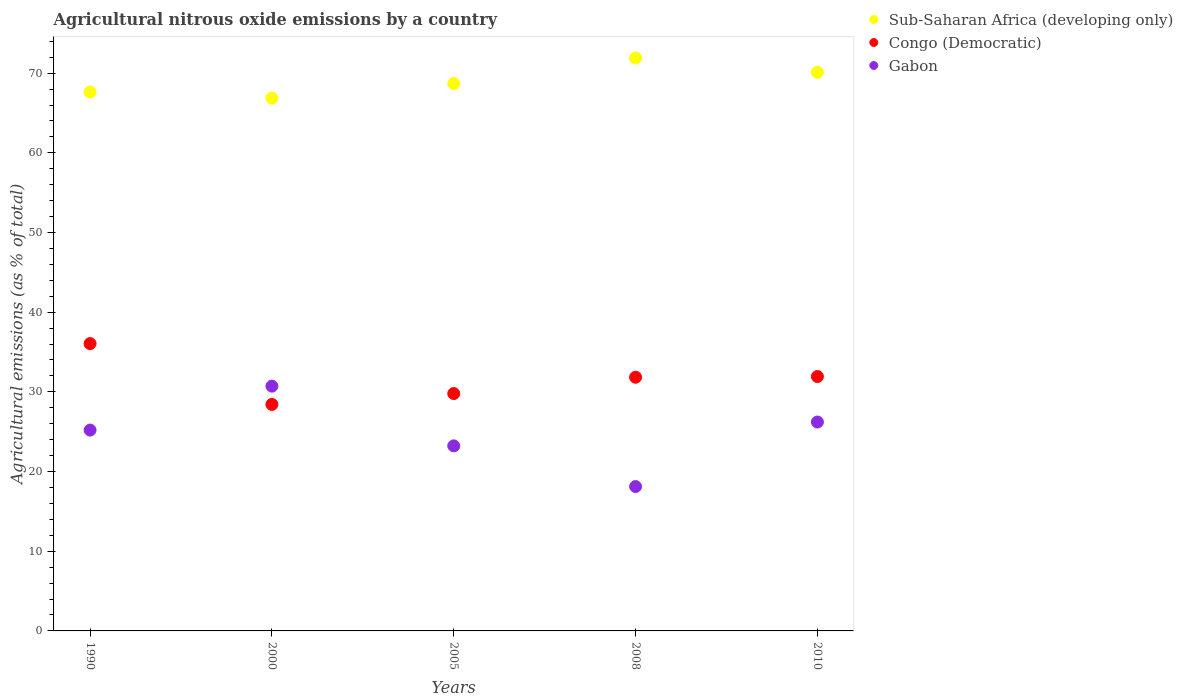How many different coloured dotlines are there?
Offer a very short reply. 3. Is the number of dotlines equal to the number of legend labels?
Provide a short and direct response. Yes. What is the amount of agricultural nitrous oxide emitted in Congo (Democratic) in 1990?
Ensure brevity in your answer.  36.06. Across all years, what is the maximum amount of agricultural nitrous oxide emitted in Gabon?
Offer a very short reply. 30.72. Across all years, what is the minimum amount of agricultural nitrous oxide emitted in Congo (Democratic)?
Offer a very short reply. 28.43. In which year was the amount of agricultural nitrous oxide emitted in Sub-Saharan Africa (developing only) maximum?
Your answer should be compact. 2008. In which year was the amount of agricultural nitrous oxide emitted in Congo (Democratic) minimum?
Give a very brief answer. 2000. What is the total amount of agricultural nitrous oxide emitted in Congo (Democratic) in the graph?
Your response must be concise. 158.03. What is the difference between the amount of agricultural nitrous oxide emitted in Gabon in 2000 and that in 2010?
Provide a succinct answer. 4.5. What is the difference between the amount of agricultural nitrous oxide emitted in Sub-Saharan Africa (developing only) in 2005 and the amount of agricultural nitrous oxide emitted in Gabon in 1990?
Provide a succinct answer. 43.49. What is the average amount of agricultural nitrous oxide emitted in Congo (Democratic) per year?
Keep it short and to the point. 31.61. In the year 2000, what is the difference between the amount of agricultural nitrous oxide emitted in Sub-Saharan Africa (developing only) and amount of agricultural nitrous oxide emitted in Gabon?
Your answer should be very brief. 36.14. What is the ratio of the amount of agricultural nitrous oxide emitted in Sub-Saharan Africa (developing only) in 2000 to that in 2005?
Your answer should be compact. 0.97. Is the amount of agricultural nitrous oxide emitted in Congo (Democratic) in 1990 less than that in 2010?
Your answer should be very brief. No. Is the difference between the amount of agricultural nitrous oxide emitted in Sub-Saharan Africa (developing only) in 2005 and 2008 greater than the difference between the amount of agricultural nitrous oxide emitted in Gabon in 2005 and 2008?
Your response must be concise. No. What is the difference between the highest and the second highest amount of agricultural nitrous oxide emitted in Congo (Democratic)?
Offer a very short reply. 4.13. What is the difference between the highest and the lowest amount of agricultural nitrous oxide emitted in Congo (Democratic)?
Offer a terse response. 7.63. In how many years, is the amount of agricultural nitrous oxide emitted in Gabon greater than the average amount of agricultural nitrous oxide emitted in Gabon taken over all years?
Ensure brevity in your answer.  3. Is the sum of the amount of agricultural nitrous oxide emitted in Congo (Democratic) in 1990 and 2010 greater than the maximum amount of agricultural nitrous oxide emitted in Sub-Saharan Africa (developing only) across all years?
Ensure brevity in your answer.  No. How many dotlines are there?
Offer a very short reply. 3. How many years are there in the graph?
Offer a very short reply. 5. Does the graph contain grids?
Offer a terse response. No. Where does the legend appear in the graph?
Your answer should be compact. Top right. How many legend labels are there?
Your answer should be very brief. 3. What is the title of the graph?
Your answer should be compact. Agricultural nitrous oxide emissions by a country. Does "Macao" appear as one of the legend labels in the graph?
Give a very brief answer. No. What is the label or title of the X-axis?
Keep it short and to the point. Years. What is the label or title of the Y-axis?
Your answer should be compact. Agricultural emissions (as % of total). What is the Agricultural emissions (as % of total) of Sub-Saharan Africa (developing only) in 1990?
Keep it short and to the point. 67.62. What is the Agricultural emissions (as % of total) in Congo (Democratic) in 1990?
Make the answer very short. 36.06. What is the Agricultural emissions (as % of total) of Gabon in 1990?
Provide a succinct answer. 25.2. What is the Agricultural emissions (as % of total) of Sub-Saharan Africa (developing only) in 2000?
Your answer should be compact. 66.86. What is the Agricultural emissions (as % of total) of Congo (Democratic) in 2000?
Provide a succinct answer. 28.43. What is the Agricultural emissions (as % of total) of Gabon in 2000?
Give a very brief answer. 30.72. What is the Agricultural emissions (as % of total) in Sub-Saharan Africa (developing only) in 2005?
Your response must be concise. 68.7. What is the Agricultural emissions (as % of total) of Congo (Democratic) in 2005?
Your answer should be very brief. 29.79. What is the Agricultural emissions (as % of total) in Gabon in 2005?
Make the answer very short. 23.22. What is the Agricultural emissions (as % of total) in Sub-Saharan Africa (developing only) in 2008?
Your answer should be very brief. 71.9. What is the Agricultural emissions (as % of total) in Congo (Democratic) in 2008?
Make the answer very short. 31.84. What is the Agricultural emissions (as % of total) of Gabon in 2008?
Your response must be concise. 18.12. What is the Agricultural emissions (as % of total) of Sub-Saharan Africa (developing only) in 2010?
Your response must be concise. 70.1. What is the Agricultural emissions (as % of total) in Congo (Democratic) in 2010?
Ensure brevity in your answer.  31.92. What is the Agricultural emissions (as % of total) in Gabon in 2010?
Keep it short and to the point. 26.21. Across all years, what is the maximum Agricultural emissions (as % of total) in Sub-Saharan Africa (developing only)?
Offer a very short reply. 71.9. Across all years, what is the maximum Agricultural emissions (as % of total) in Congo (Democratic)?
Give a very brief answer. 36.06. Across all years, what is the maximum Agricultural emissions (as % of total) of Gabon?
Provide a succinct answer. 30.72. Across all years, what is the minimum Agricultural emissions (as % of total) of Sub-Saharan Africa (developing only)?
Give a very brief answer. 66.86. Across all years, what is the minimum Agricultural emissions (as % of total) in Congo (Democratic)?
Your answer should be compact. 28.43. Across all years, what is the minimum Agricultural emissions (as % of total) in Gabon?
Provide a succinct answer. 18.12. What is the total Agricultural emissions (as % of total) of Sub-Saharan Africa (developing only) in the graph?
Make the answer very short. 345.18. What is the total Agricultural emissions (as % of total) in Congo (Democratic) in the graph?
Your answer should be compact. 158.03. What is the total Agricultural emissions (as % of total) in Gabon in the graph?
Your response must be concise. 123.48. What is the difference between the Agricultural emissions (as % of total) of Sub-Saharan Africa (developing only) in 1990 and that in 2000?
Give a very brief answer. 0.76. What is the difference between the Agricultural emissions (as % of total) of Congo (Democratic) in 1990 and that in 2000?
Offer a terse response. 7.63. What is the difference between the Agricultural emissions (as % of total) of Gabon in 1990 and that in 2000?
Make the answer very short. -5.51. What is the difference between the Agricultural emissions (as % of total) in Sub-Saharan Africa (developing only) in 1990 and that in 2005?
Make the answer very short. -1.08. What is the difference between the Agricultural emissions (as % of total) of Congo (Democratic) in 1990 and that in 2005?
Ensure brevity in your answer.  6.27. What is the difference between the Agricultural emissions (as % of total) of Gabon in 1990 and that in 2005?
Make the answer very short. 1.98. What is the difference between the Agricultural emissions (as % of total) in Sub-Saharan Africa (developing only) in 1990 and that in 2008?
Provide a succinct answer. -4.28. What is the difference between the Agricultural emissions (as % of total) of Congo (Democratic) in 1990 and that in 2008?
Provide a short and direct response. 4.22. What is the difference between the Agricultural emissions (as % of total) in Gabon in 1990 and that in 2008?
Ensure brevity in your answer.  7.09. What is the difference between the Agricultural emissions (as % of total) in Sub-Saharan Africa (developing only) in 1990 and that in 2010?
Your answer should be compact. -2.48. What is the difference between the Agricultural emissions (as % of total) of Congo (Democratic) in 1990 and that in 2010?
Your response must be concise. 4.13. What is the difference between the Agricultural emissions (as % of total) in Gabon in 1990 and that in 2010?
Offer a very short reply. -1.01. What is the difference between the Agricultural emissions (as % of total) of Sub-Saharan Africa (developing only) in 2000 and that in 2005?
Your answer should be compact. -1.84. What is the difference between the Agricultural emissions (as % of total) in Congo (Democratic) in 2000 and that in 2005?
Give a very brief answer. -1.36. What is the difference between the Agricultural emissions (as % of total) of Gabon in 2000 and that in 2005?
Keep it short and to the point. 7.49. What is the difference between the Agricultural emissions (as % of total) of Sub-Saharan Africa (developing only) in 2000 and that in 2008?
Your response must be concise. -5.04. What is the difference between the Agricultural emissions (as % of total) of Congo (Democratic) in 2000 and that in 2008?
Your answer should be very brief. -3.41. What is the difference between the Agricultural emissions (as % of total) in Gabon in 2000 and that in 2008?
Ensure brevity in your answer.  12.6. What is the difference between the Agricultural emissions (as % of total) in Sub-Saharan Africa (developing only) in 2000 and that in 2010?
Provide a short and direct response. -3.24. What is the difference between the Agricultural emissions (as % of total) of Congo (Democratic) in 2000 and that in 2010?
Make the answer very short. -3.5. What is the difference between the Agricultural emissions (as % of total) of Gabon in 2000 and that in 2010?
Your answer should be compact. 4.5. What is the difference between the Agricultural emissions (as % of total) in Sub-Saharan Africa (developing only) in 2005 and that in 2008?
Offer a very short reply. -3.2. What is the difference between the Agricultural emissions (as % of total) of Congo (Democratic) in 2005 and that in 2008?
Make the answer very short. -2.05. What is the difference between the Agricultural emissions (as % of total) of Gabon in 2005 and that in 2008?
Your answer should be compact. 5.11. What is the difference between the Agricultural emissions (as % of total) of Sub-Saharan Africa (developing only) in 2005 and that in 2010?
Provide a succinct answer. -1.41. What is the difference between the Agricultural emissions (as % of total) of Congo (Democratic) in 2005 and that in 2010?
Give a very brief answer. -2.13. What is the difference between the Agricultural emissions (as % of total) of Gabon in 2005 and that in 2010?
Ensure brevity in your answer.  -2.99. What is the difference between the Agricultural emissions (as % of total) in Sub-Saharan Africa (developing only) in 2008 and that in 2010?
Make the answer very short. 1.79. What is the difference between the Agricultural emissions (as % of total) in Congo (Democratic) in 2008 and that in 2010?
Your answer should be very brief. -0.09. What is the difference between the Agricultural emissions (as % of total) in Gabon in 2008 and that in 2010?
Offer a terse response. -8.1. What is the difference between the Agricultural emissions (as % of total) of Sub-Saharan Africa (developing only) in 1990 and the Agricultural emissions (as % of total) of Congo (Democratic) in 2000?
Make the answer very short. 39.19. What is the difference between the Agricultural emissions (as % of total) in Sub-Saharan Africa (developing only) in 1990 and the Agricultural emissions (as % of total) in Gabon in 2000?
Give a very brief answer. 36.9. What is the difference between the Agricultural emissions (as % of total) of Congo (Democratic) in 1990 and the Agricultural emissions (as % of total) of Gabon in 2000?
Your response must be concise. 5.34. What is the difference between the Agricultural emissions (as % of total) in Sub-Saharan Africa (developing only) in 1990 and the Agricultural emissions (as % of total) in Congo (Democratic) in 2005?
Your answer should be very brief. 37.83. What is the difference between the Agricultural emissions (as % of total) in Sub-Saharan Africa (developing only) in 1990 and the Agricultural emissions (as % of total) in Gabon in 2005?
Provide a succinct answer. 44.4. What is the difference between the Agricultural emissions (as % of total) in Congo (Democratic) in 1990 and the Agricultural emissions (as % of total) in Gabon in 2005?
Make the answer very short. 12.83. What is the difference between the Agricultural emissions (as % of total) in Sub-Saharan Africa (developing only) in 1990 and the Agricultural emissions (as % of total) in Congo (Democratic) in 2008?
Ensure brevity in your answer.  35.78. What is the difference between the Agricultural emissions (as % of total) of Sub-Saharan Africa (developing only) in 1990 and the Agricultural emissions (as % of total) of Gabon in 2008?
Offer a very short reply. 49.5. What is the difference between the Agricultural emissions (as % of total) in Congo (Democratic) in 1990 and the Agricultural emissions (as % of total) in Gabon in 2008?
Give a very brief answer. 17.94. What is the difference between the Agricultural emissions (as % of total) of Sub-Saharan Africa (developing only) in 1990 and the Agricultural emissions (as % of total) of Congo (Democratic) in 2010?
Your answer should be compact. 35.7. What is the difference between the Agricultural emissions (as % of total) in Sub-Saharan Africa (developing only) in 1990 and the Agricultural emissions (as % of total) in Gabon in 2010?
Make the answer very short. 41.41. What is the difference between the Agricultural emissions (as % of total) of Congo (Democratic) in 1990 and the Agricultural emissions (as % of total) of Gabon in 2010?
Give a very brief answer. 9.84. What is the difference between the Agricultural emissions (as % of total) of Sub-Saharan Africa (developing only) in 2000 and the Agricultural emissions (as % of total) of Congo (Democratic) in 2005?
Your answer should be very brief. 37.07. What is the difference between the Agricultural emissions (as % of total) of Sub-Saharan Africa (developing only) in 2000 and the Agricultural emissions (as % of total) of Gabon in 2005?
Ensure brevity in your answer.  43.63. What is the difference between the Agricultural emissions (as % of total) in Congo (Democratic) in 2000 and the Agricultural emissions (as % of total) in Gabon in 2005?
Keep it short and to the point. 5.2. What is the difference between the Agricultural emissions (as % of total) of Sub-Saharan Africa (developing only) in 2000 and the Agricultural emissions (as % of total) of Congo (Democratic) in 2008?
Your answer should be compact. 35.02. What is the difference between the Agricultural emissions (as % of total) in Sub-Saharan Africa (developing only) in 2000 and the Agricultural emissions (as % of total) in Gabon in 2008?
Give a very brief answer. 48.74. What is the difference between the Agricultural emissions (as % of total) of Congo (Democratic) in 2000 and the Agricultural emissions (as % of total) of Gabon in 2008?
Provide a succinct answer. 10.31. What is the difference between the Agricultural emissions (as % of total) of Sub-Saharan Africa (developing only) in 2000 and the Agricultural emissions (as % of total) of Congo (Democratic) in 2010?
Offer a very short reply. 34.93. What is the difference between the Agricultural emissions (as % of total) in Sub-Saharan Africa (developing only) in 2000 and the Agricultural emissions (as % of total) in Gabon in 2010?
Your response must be concise. 40.64. What is the difference between the Agricultural emissions (as % of total) in Congo (Democratic) in 2000 and the Agricultural emissions (as % of total) in Gabon in 2010?
Offer a terse response. 2.21. What is the difference between the Agricultural emissions (as % of total) of Sub-Saharan Africa (developing only) in 2005 and the Agricultural emissions (as % of total) of Congo (Democratic) in 2008?
Provide a short and direct response. 36.86. What is the difference between the Agricultural emissions (as % of total) in Sub-Saharan Africa (developing only) in 2005 and the Agricultural emissions (as % of total) in Gabon in 2008?
Give a very brief answer. 50.58. What is the difference between the Agricultural emissions (as % of total) of Congo (Democratic) in 2005 and the Agricultural emissions (as % of total) of Gabon in 2008?
Offer a very short reply. 11.67. What is the difference between the Agricultural emissions (as % of total) of Sub-Saharan Africa (developing only) in 2005 and the Agricultural emissions (as % of total) of Congo (Democratic) in 2010?
Offer a terse response. 36.77. What is the difference between the Agricultural emissions (as % of total) in Sub-Saharan Africa (developing only) in 2005 and the Agricultural emissions (as % of total) in Gabon in 2010?
Your answer should be very brief. 42.48. What is the difference between the Agricultural emissions (as % of total) of Congo (Democratic) in 2005 and the Agricultural emissions (as % of total) of Gabon in 2010?
Your response must be concise. 3.57. What is the difference between the Agricultural emissions (as % of total) in Sub-Saharan Africa (developing only) in 2008 and the Agricultural emissions (as % of total) in Congo (Democratic) in 2010?
Give a very brief answer. 39.97. What is the difference between the Agricultural emissions (as % of total) of Sub-Saharan Africa (developing only) in 2008 and the Agricultural emissions (as % of total) of Gabon in 2010?
Keep it short and to the point. 45.68. What is the difference between the Agricultural emissions (as % of total) in Congo (Democratic) in 2008 and the Agricultural emissions (as % of total) in Gabon in 2010?
Your answer should be very brief. 5.62. What is the average Agricultural emissions (as % of total) in Sub-Saharan Africa (developing only) per year?
Make the answer very short. 69.04. What is the average Agricultural emissions (as % of total) in Congo (Democratic) per year?
Keep it short and to the point. 31.61. What is the average Agricultural emissions (as % of total) of Gabon per year?
Your response must be concise. 24.7. In the year 1990, what is the difference between the Agricultural emissions (as % of total) in Sub-Saharan Africa (developing only) and Agricultural emissions (as % of total) in Congo (Democratic)?
Provide a short and direct response. 31.56. In the year 1990, what is the difference between the Agricultural emissions (as % of total) in Sub-Saharan Africa (developing only) and Agricultural emissions (as % of total) in Gabon?
Your answer should be very brief. 42.42. In the year 1990, what is the difference between the Agricultural emissions (as % of total) of Congo (Democratic) and Agricultural emissions (as % of total) of Gabon?
Keep it short and to the point. 10.85. In the year 2000, what is the difference between the Agricultural emissions (as % of total) of Sub-Saharan Africa (developing only) and Agricultural emissions (as % of total) of Congo (Democratic)?
Your answer should be compact. 38.43. In the year 2000, what is the difference between the Agricultural emissions (as % of total) in Sub-Saharan Africa (developing only) and Agricultural emissions (as % of total) in Gabon?
Offer a very short reply. 36.14. In the year 2000, what is the difference between the Agricultural emissions (as % of total) in Congo (Democratic) and Agricultural emissions (as % of total) in Gabon?
Your response must be concise. -2.29. In the year 2005, what is the difference between the Agricultural emissions (as % of total) of Sub-Saharan Africa (developing only) and Agricultural emissions (as % of total) of Congo (Democratic)?
Your response must be concise. 38.91. In the year 2005, what is the difference between the Agricultural emissions (as % of total) of Sub-Saharan Africa (developing only) and Agricultural emissions (as % of total) of Gabon?
Your answer should be compact. 45.47. In the year 2005, what is the difference between the Agricultural emissions (as % of total) of Congo (Democratic) and Agricultural emissions (as % of total) of Gabon?
Your response must be concise. 6.57. In the year 2008, what is the difference between the Agricultural emissions (as % of total) in Sub-Saharan Africa (developing only) and Agricultural emissions (as % of total) in Congo (Democratic)?
Your answer should be compact. 40.06. In the year 2008, what is the difference between the Agricultural emissions (as % of total) of Sub-Saharan Africa (developing only) and Agricultural emissions (as % of total) of Gabon?
Your answer should be compact. 53.78. In the year 2008, what is the difference between the Agricultural emissions (as % of total) of Congo (Democratic) and Agricultural emissions (as % of total) of Gabon?
Give a very brief answer. 13.72. In the year 2010, what is the difference between the Agricultural emissions (as % of total) of Sub-Saharan Africa (developing only) and Agricultural emissions (as % of total) of Congo (Democratic)?
Offer a terse response. 38.18. In the year 2010, what is the difference between the Agricultural emissions (as % of total) of Sub-Saharan Africa (developing only) and Agricultural emissions (as % of total) of Gabon?
Offer a very short reply. 43.89. In the year 2010, what is the difference between the Agricultural emissions (as % of total) of Congo (Democratic) and Agricultural emissions (as % of total) of Gabon?
Your response must be concise. 5.71. What is the ratio of the Agricultural emissions (as % of total) in Sub-Saharan Africa (developing only) in 1990 to that in 2000?
Make the answer very short. 1.01. What is the ratio of the Agricultural emissions (as % of total) in Congo (Democratic) in 1990 to that in 2000?
Provide a short and direct response. 1.27. What is the ratio of the Agricultural emissions (as % of total) in Gabon in 1990 to that in 2000?
Your answer should be compact. 0.82. What is the ratio of the Agricultural emissions (as % of total) of Sub-Saharan Africa (developing only) in 1990 to that in 2005?
Make the answer very short. 0.98. What is the ratio of the Agricultural emissions (as % of total) in Congo (Democratic) in 1990 to that in 2005?
Provide a succinct answer. 1.21. What is the ratio of the Agricultural emissions (as % of total) of Gabon in 1990 to that in 2005?
Make the answer very short. 1.09. What is the ratio of the Agricultural emissions (as % of total) of Sub-Saharan Africa (developing only) in 1990 to that in 2008?
Offer a very short reply. 0.94. What is the ratio of the Agricultural emissions (as % of total) of Congo (Democratic) in 1990 to that in 2008?
Offer a terse response. 1.13. What is the ratio of the Agricultural emissions (as % of total) in Gabon in 1990 to that in 2008?
Give a very brief answer. 1.39. What is the ratio of the Agricultural emissions (as % of total) in Sub-Saharan Africa (developing only) in 1990 to that in 2010?
Make the answer very short. 0.96. What is the ratio of the Agricultural emissions (as % of total) in Congo (Democratic) in 1990 to that in 2010?
Give a very brief answer. 1.13. What is the ratio of the Agricultural emissions (as % of total) in Gabon in 1990 to that in 2010?
Your answer should be very brief. 0.96. What is the ratio of the Agricultural emissions (as % of total) in Sub-Saharan Africa (developing only) in 2000 to that in 2005?
Offer a terse response. 0.97. What is the ratio of the Agricultural emissions (as % of total) in Congo (Democratic) in 2000 to that in 2005?
Keep it short and to the point. 0.95. What is the ratio of the Agricultural emissions (as % of total) of Gabon in 2000 to that in 2005?
Your response must be concise. 1.32. What is the ratio of the Agricultural emissions (as % of total) of Sub-Saharan Africa (developing only) in 2000 to that in 2008?
Your response must be concise. 0.93. What is the ratio of the Agricultural emissions (as % of total) in Congo (Democratic) in 2000 to that in 2008?
Ensure brevity in your answer.  0.89. What is the ratio of the Agricultural emissions (as % of total) in Gabon in 2000 to that in 2008?
Offer a very short reply. 1.7. What is the ratio of the Agricultural emissions (as % of total) of Sub-Saharan Africa (developing only) in 2000 to that in 2010?
Your answer should be very brief. 0.95. What is the ratio of the Agricultural emissions (as % of total) of Congo (Democratic) in 2000 to that in 2010?
Keep it short and to the point. 0.89. What is the ratio of the Agricultural emissions (as % of total) in Gabon in 2000 to that in 2010?
Provide a short and direct response. 1.17. What is the ratio of the Agricultural emissions (as % of total) in Sub-Saharan Africa (developing only) in 2005 to that in 2008?
Give a very brief answer. 0.96. What is the ratio of the Agricultural emissions (as % of total) in Congo (Democratic) in 2005 to that in 2008?
Provide a succinct answer. 0.94. What is the ratio of the Agricultural emissions (as % of total) in Gabon in 2005 to that in 2008?
Give a very brief answer. 1.28. What is the ratio of the Agricultural emissions (as % of total) of Sub-Saharan Africa (developing only) in 2005 to that in 2010?
Provide a short and direct response. 0.98. What is the ratio of the Agricultural emissions (as % of total) in Congo (Democratic) in 2005 to that in 2010?
Provide a short and direct response. 0.93. What is the ratio of the Agricultural emissions (as % of total) of Gabon in 2005 to that in 2010?
Your answer should be compact. 0.89. What is the ratio of the Agricultural emissions (as % of total) of Sub-Saharan Africa (developing only) in 2008 to that in 2010?
Provide a short and direct response. 1.03. What is the ratio of the Agricultural emissions (as % of total) of Gabon in 2008 to that in 2010?
Offer a terse response. 0.69. What is the difference between the highest and the second highest Agricultural emissions (as % of total) in Sub-Saharan Africa (developing only)?
Offer a very short reply. 1.79. What is the difference between the highest and the second highest Agricultural emissions (as % of total) of Congo (Democratic)?
Your answer should be compact. 4.13. What is the difference between the highest and the second highest Agricultural emissions (as % of total) in Gabon?
Ensure brevity in your answer.  4.5. What is the difference between the highest and the lowest Agricultural emissions (as % of total) of Sub-Saharan Africa (developing only)?
Keep it short and to the point. 5.04. What is the difference between the highest and the lowest Agricultural emissions (as % of total) in Congo (Democratic)?
Offer a terse response. 7.63. What is the difference between the highest and the lowest Agricultural emissions (as % of total) of Gabon?
Provide a short and direct response. 12.6. 